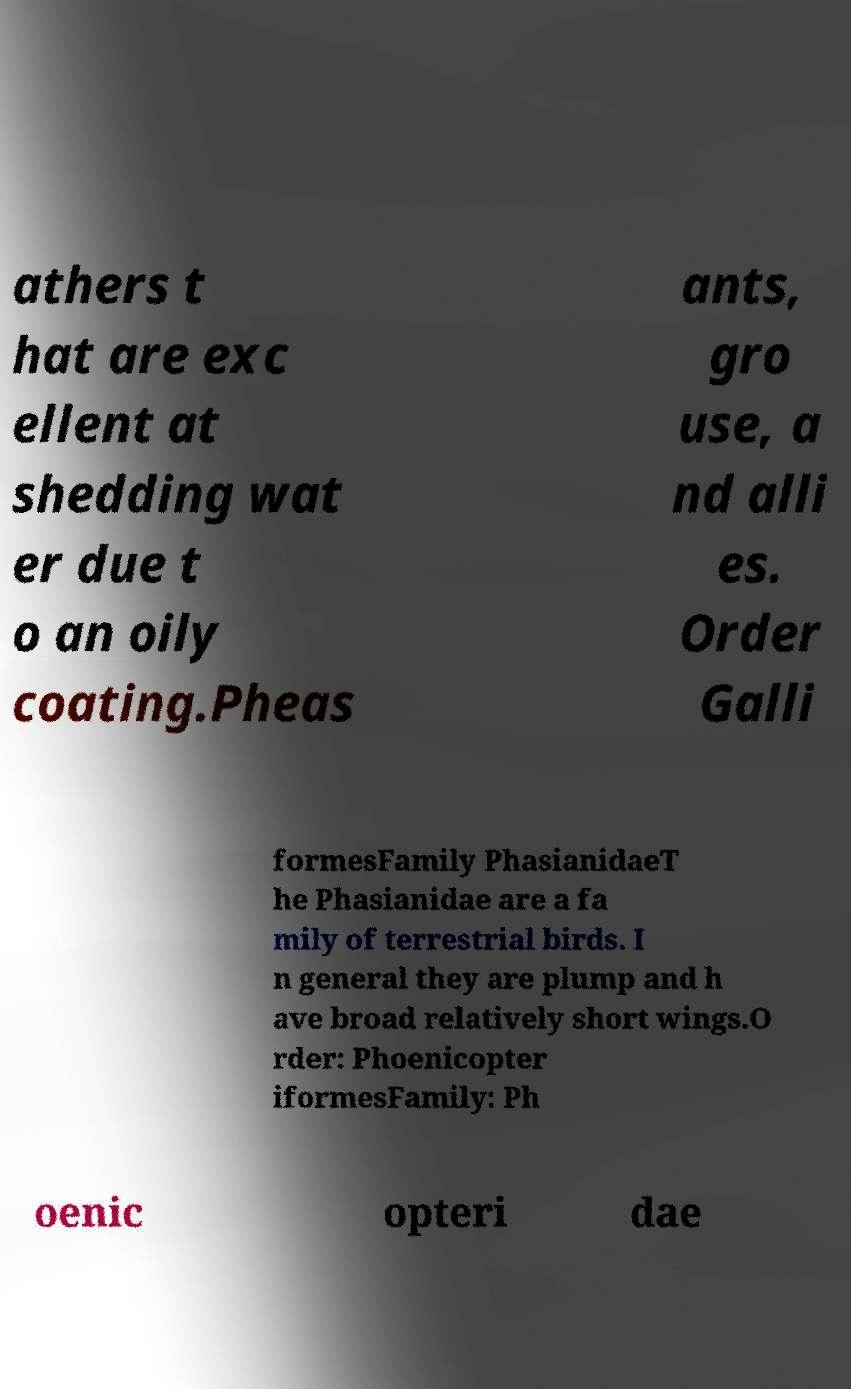There's text embedded in this image that I need extracted. Can you transcribe it verbatim? athers t hat are exc ellent at shedding wat er due t o an oily coating.Pheas ants, gro use, a nd alli es. Order Galli formesFamily PhasianidaeT he Phasianidae are a fa mily of terrestrial birds. I n general they are plump and h ave broad relatively short wings.O rder: Phoenicopter iformesFamily: Ph oenic opteri dae 